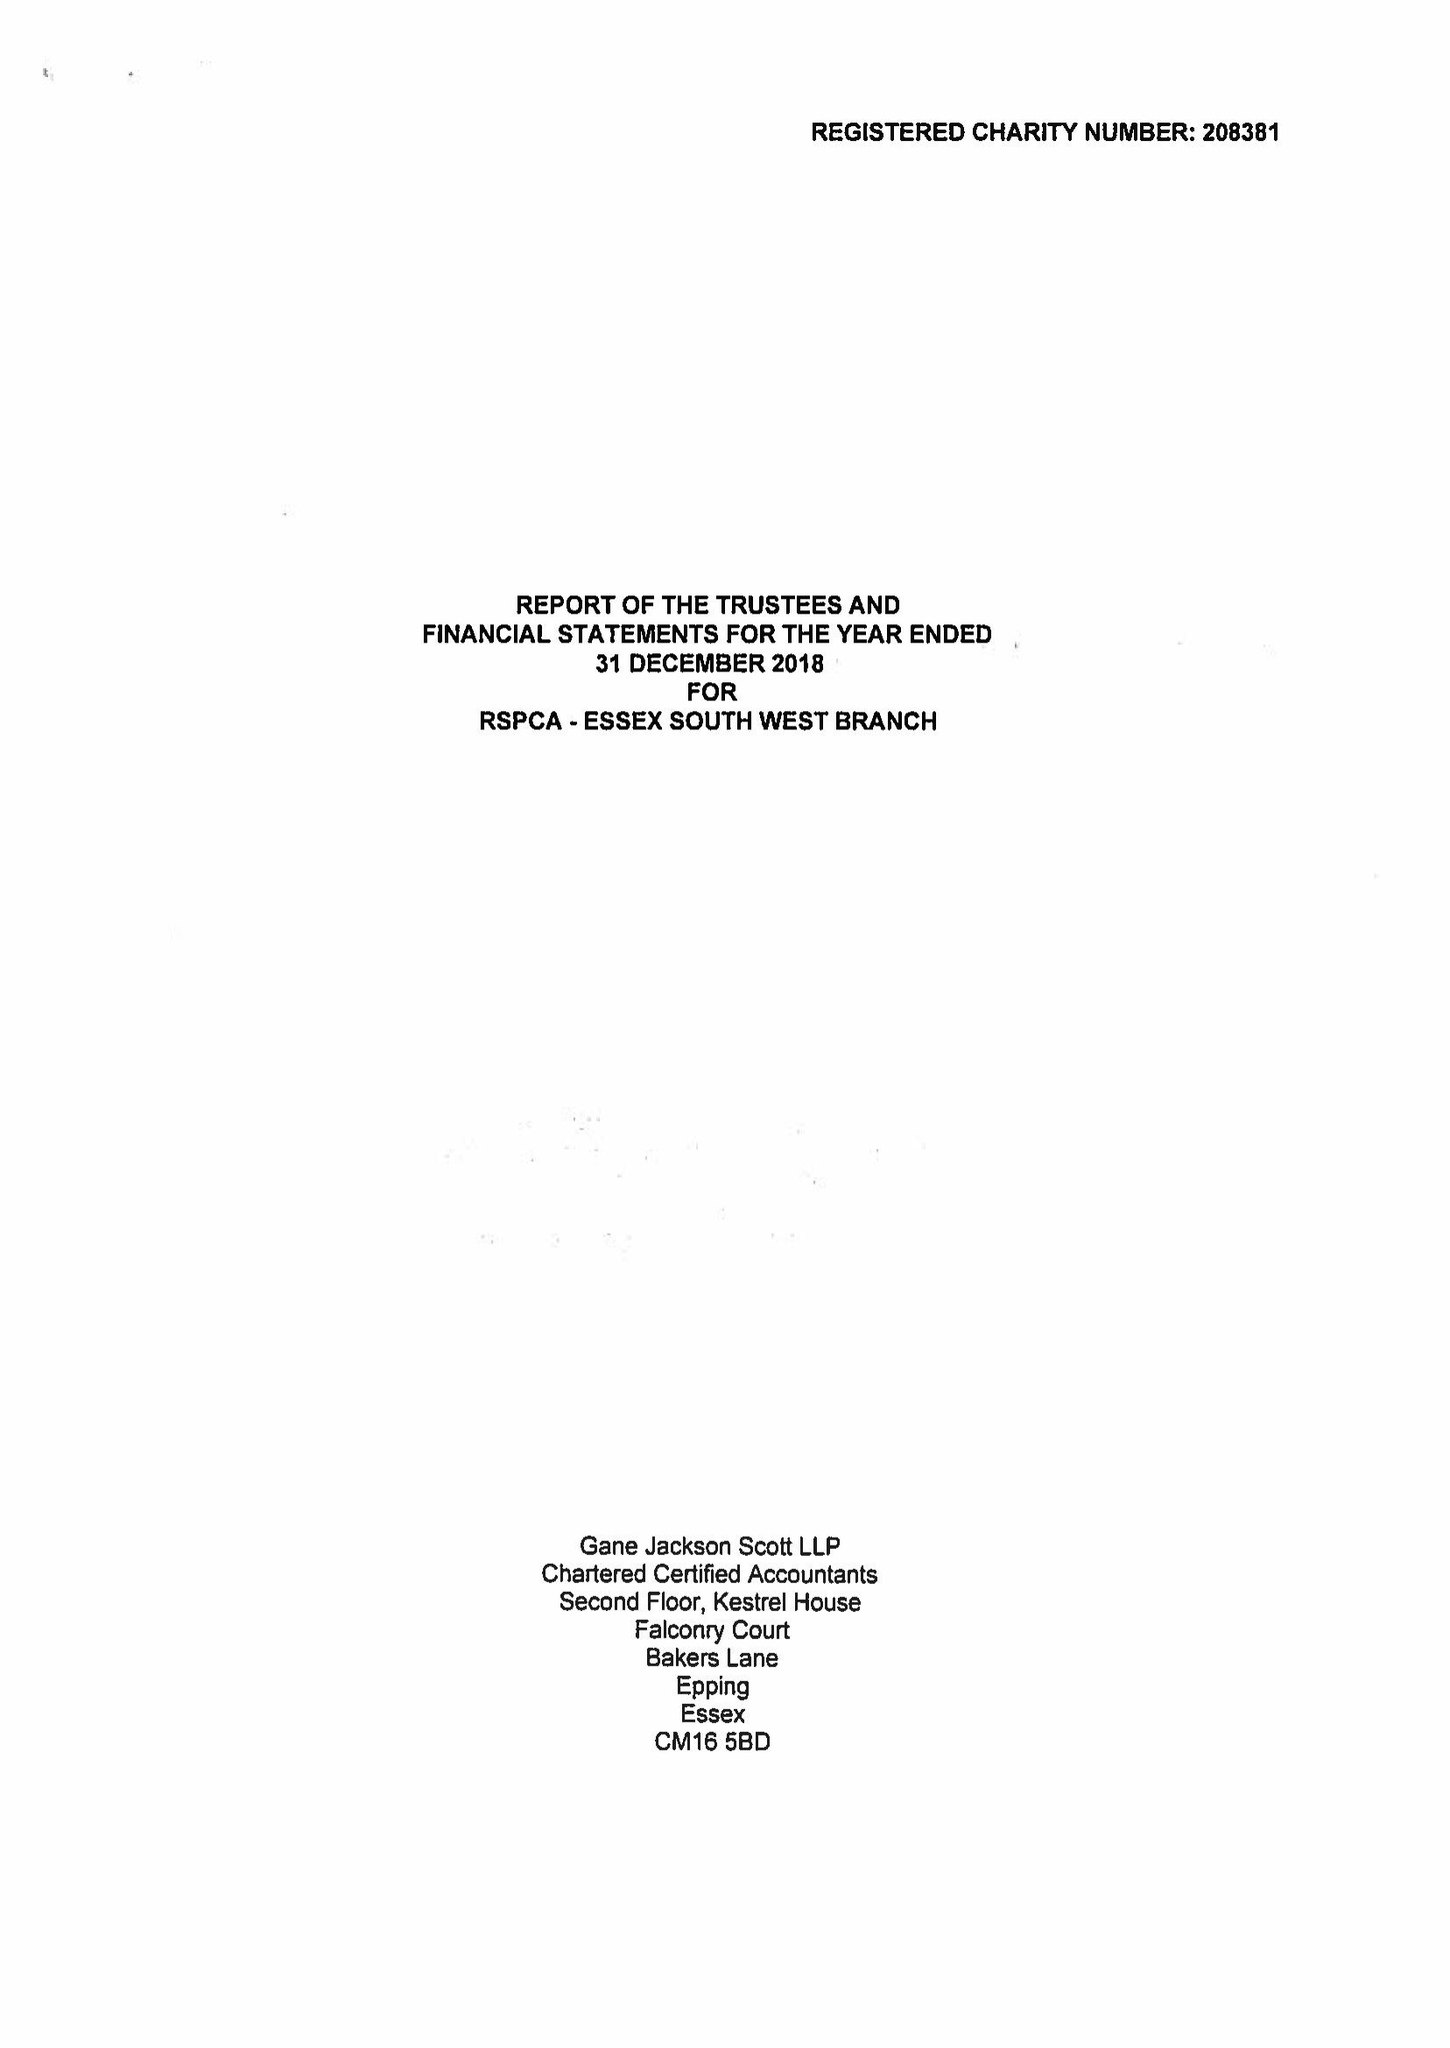What is the value for the income_annually_in_british_pounds?
Answer the question using a single word or phrase. 33312.00 